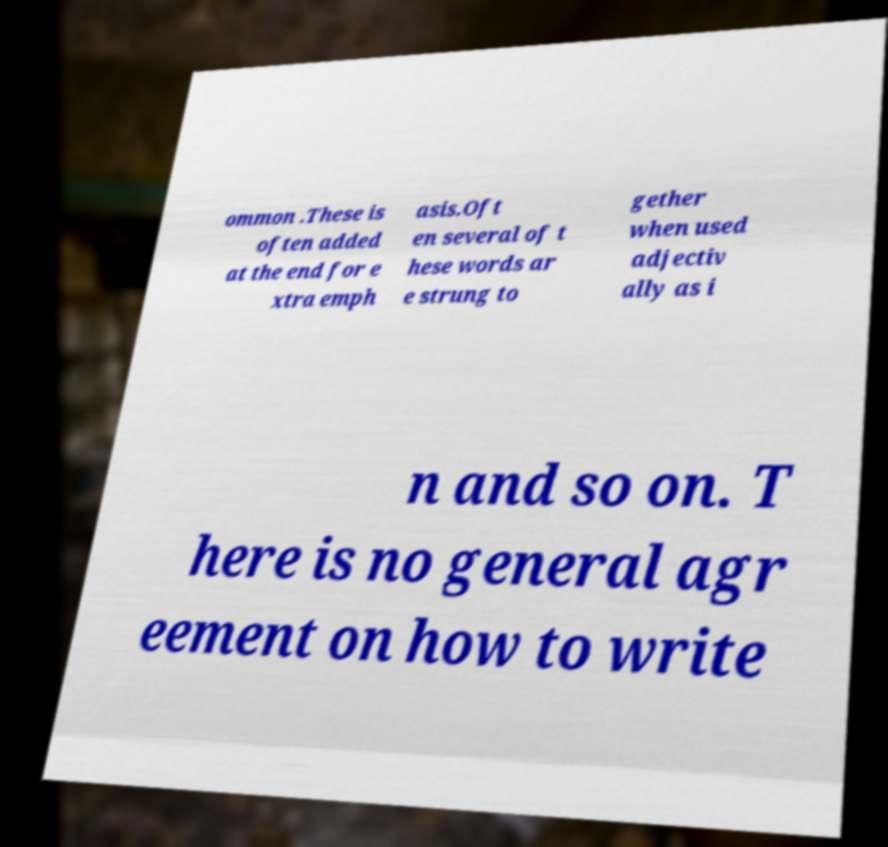Please identify and transcribe the text found in this image. ommon .These is often added at the end for e xtra emph asis.Oft en several of t hese words ar e strung to gether when used adjectiv ally as i n and so on. T here is no general agr eement on how to write 